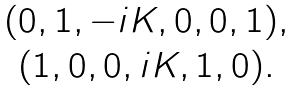<formula> <loc_0><loc_0><loc_500><loc_500>\begin{array} { c c c c c c } ( 0 , 1 , - i K , 0 , 0 , 1 ) , \\ ( 1 , 0 , 0 , i K , 1 , 0 ) . \end{array}</formula> 